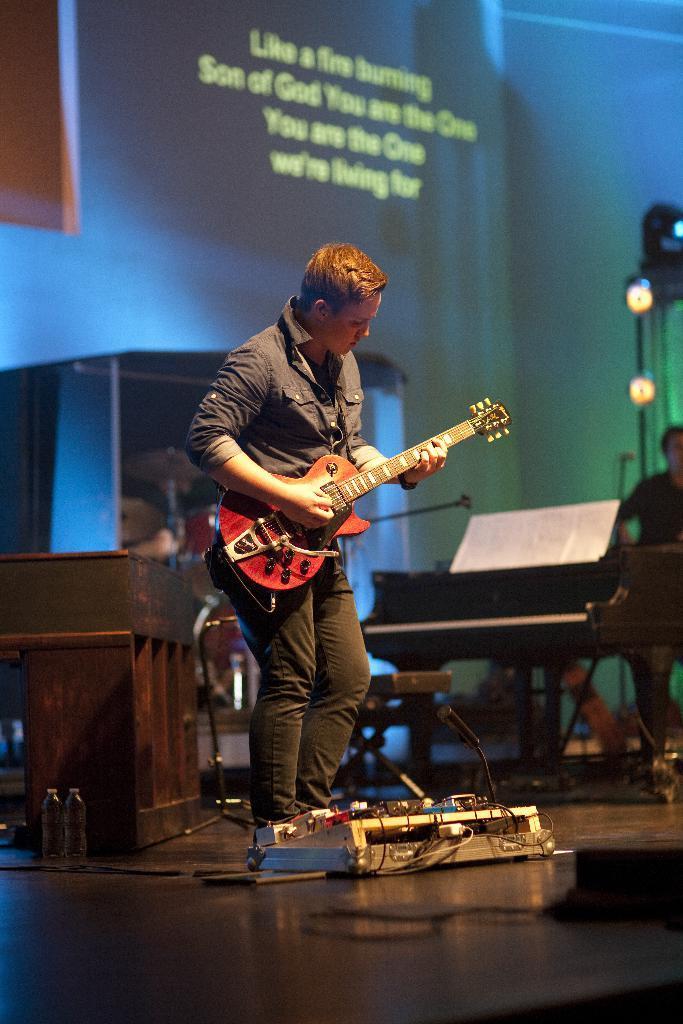Can you describe this image briefly? In this image i can see a person standing and holding a guitar. In the background i can see a piano, a screen, few lights and a person standing. 